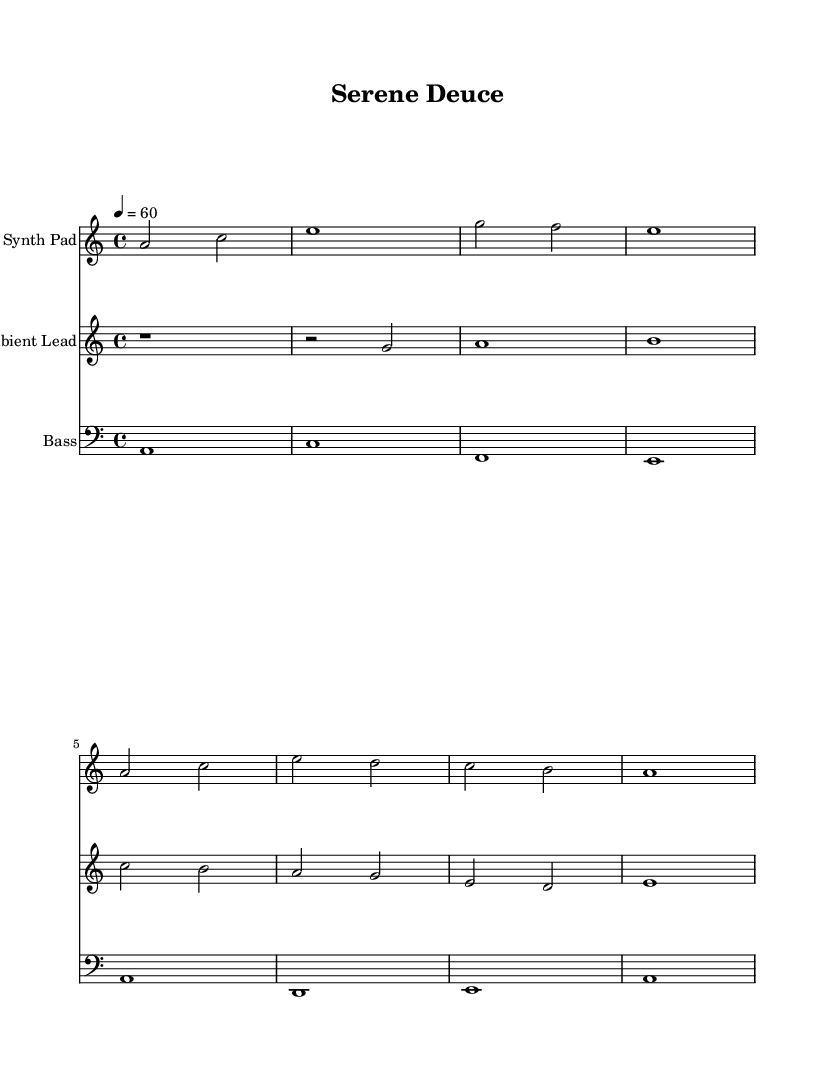What is the key signature of this music? The key signature is A minor, which has no sharps or flats. It can be identified by looking at the key signature notation at the beginning of the staff before the time signature.
Answer: A minor What is the time signature of this music? The time signature is 4/4, which indicates that there are four beats in a measure, and the quarter note gets one beat. This can be determined from the notation indicated after the key signature.
Answer: 4/4 What is the tempo marking given for this piece? The tempo marking is 60 beats per minute, indicated by the text "4 = 60" above the staff. This tells the performer the speed at which to play the music.
Answer: 60 How many measures are there in the Synth Pad part? There are five measures in the Synth Pad part, which can be counted by looking at the measure lines in the staff for the Synth Pad. Each vertical line indicates the end of a measure.
Answer: Five What is the note that starts the Ambient Lead part? The Ambient Lead part starts with a rest, which is indicated by the 'r' symbol in the sheet music. This rest signifies a pause in sound at the beginning of the part.
Answer: Rest How many unique notes are in the Bass part? There are four unique notes in the Bass part: A, C, E, and F. By visually inspecting the notes on the bass clef, the distinct pitches can be identified.
Answer: Four Which instrument plays the lowest pitch in this piece? The instrument that plays the lowest pitch is the Bass, as indicated by the notation in the bass clef, which typically represents lower pitches compared to treble clef instruments.
Answer: Bass 